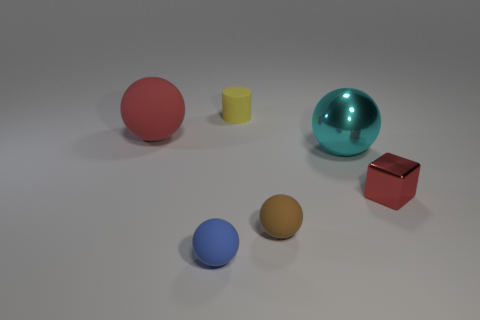Subtract all purple balls. Subtract all gray cylinders. How many balls are left? 4 Add 1 small green matte things. How many objects exist? 7 Subtract all blocks. How many objects are left? 5 Subtract 0 gray cylinders. How many objects are left? 6 Subtract all tiny red matte cylinders. Subtract all small red things. How many objects are left? 5 Add 5 big red rubber spheres. How many big red rubber spheres are left? 6 Add 1 small brown rubber things. How many small brown rubber things exist? 2 